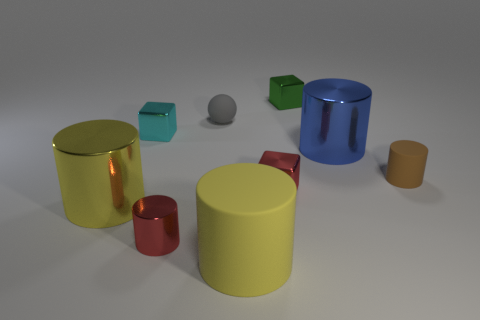What shapes are present in the image and which one is the largest? The image features several geometric shapes: cylinders, cubes, and a sphere. The largest one appears to be the yellow cylinder closest to the forefront, followed by the blue cylinder. Are the shapes arranged in any particular pattern? The shapes are not arranged in a discernible pattern; they are placed seemingly at random on a flat surface. 